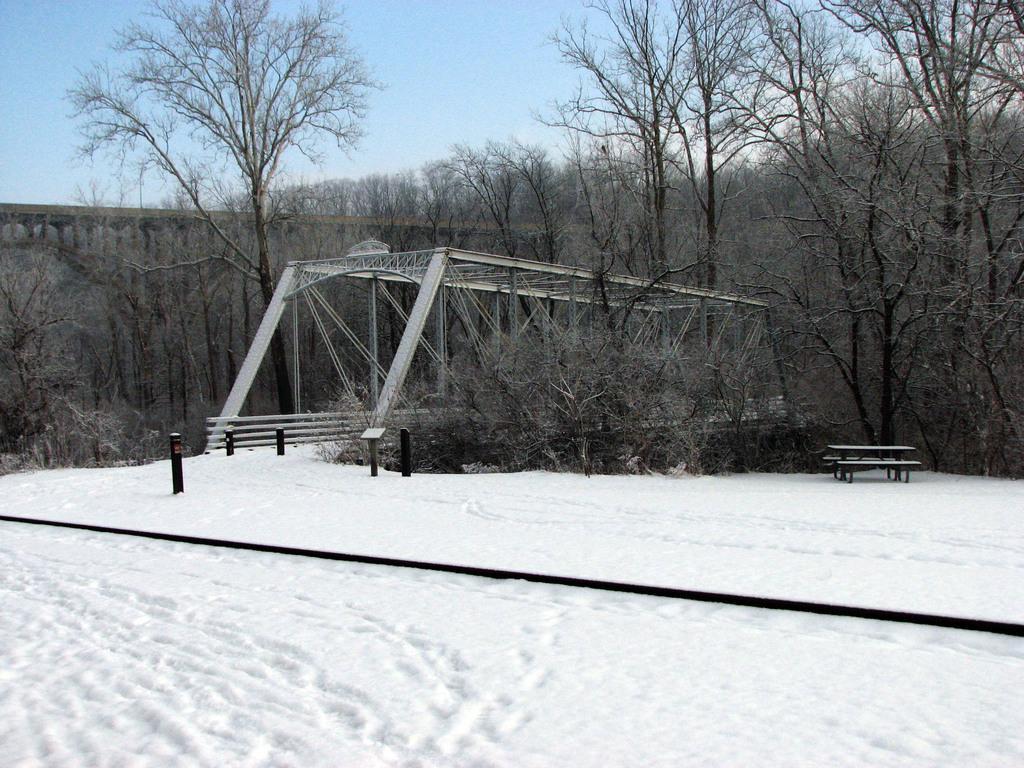Please provide a concise description of this image. This picture shows snow on the ground and we see a bridge and trees and a bench on the side and we see a blue cloudy Sky. 